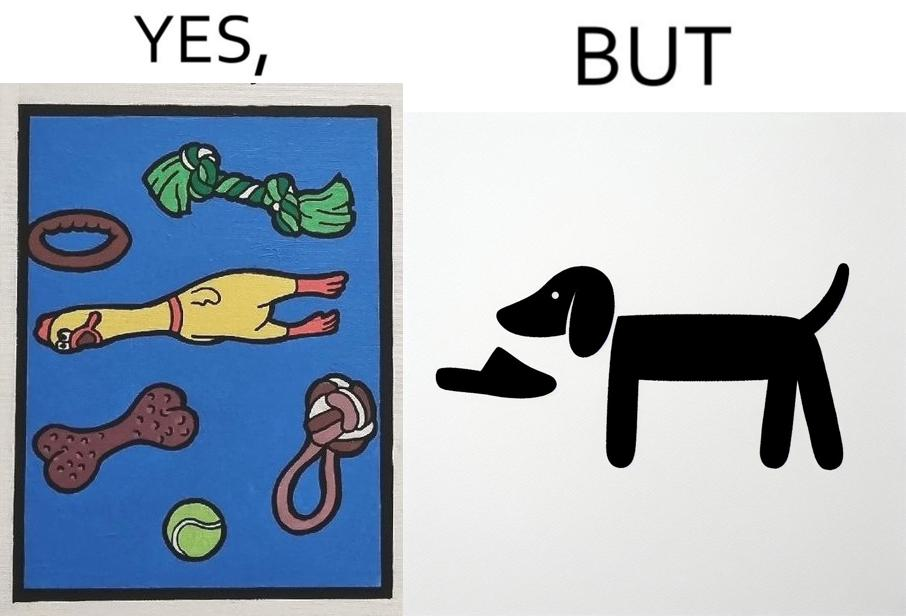Is this a satirical image? Yes, this image is satirical. 